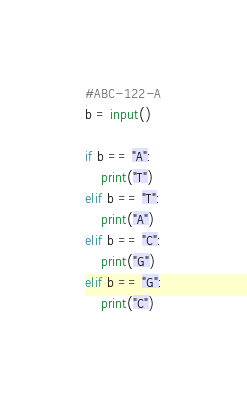Convert code to text. <code><loc_0><loc_0><loc_500><loc_500><_Python_>#ABC-122-A
b = input()

if b == "A":
    print("T")
elif b == "T":
    print("A")
elif b == "C":
    print("G")
elif b == "G":
    print("C")</code> 